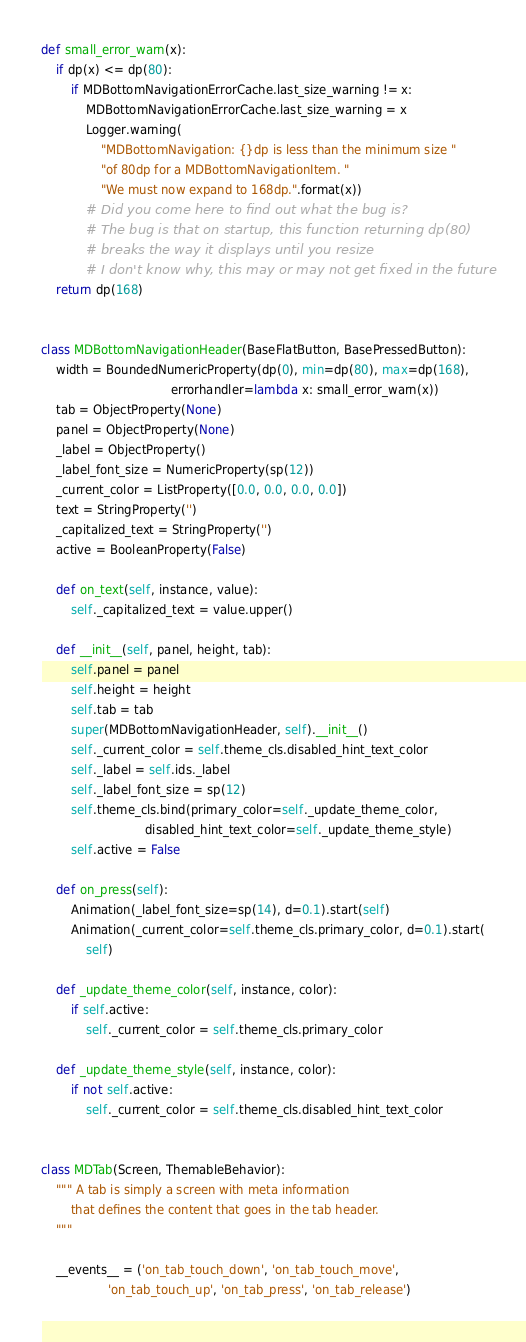<code> <loc_0><loc_0><loc_500><loc_500><_Python_>def small_error_warn(x):
    if dp(x) <= dp(80):
        if MDBottomNavigationErrorCache.last_size_warning != x:
            MDBottomNavigationErrorCache.last_size_warning = x
            Logger.warning(
                "MDBottomNavigation: {}dp is less than the minimum size "
                "of 80dp for a MDBottomNavigationItem. "
                "We must now expand to 168dp.".format(x))
            # Did you come here to find out what the bug is?
            # The bug is that on startup, this function returning dp(80)
            # breaks the way it displays until you resize
            # I don't know why, this may or may not get fixed in the future
    return dp(168)


class MDBottomNavigationHeader(BaseFlatButton, BasePressedButton):
    width = BoundedNumericProperty(dp(0), min=dp(80), max=dp(168),
                                   errorhandler=lambda x: small_error_warn(x))
    tab = ObjectProperty(None)
    panel = ObjectProperty(None)
    _label = ObjectProperty()
    _label_font_size = NumericProperty(sp(12))
    _current_color = ListProperty([0.0, 0.0, 0.0, 0.0])
    text = StringProperty('')
    _capitalized_text = StringProperty('')
    active = BooleanProperty(False)

    def on_text(self, instance, value):
        self._capitalized_text = value.upper()

    def __init__(self, panel, height, tab):
        self.panel = panel
        self.height = height
        self.tab = tab
        super(MDBottomNavigationHeader, self).__init__()
        self._current_color = self.theme_cls.disabled_hint_text_color
        self._label = self.ids._label
        self._label_font_size = sp(12)
        self.theme_cls.bind(primary_color=self._update_theme_color,
                            disabled_hint_text_color=self._update_theme_style)
        self.active = False

    def on_press(self):
        Animation(_label_font_size=sp(14), d=0.1).start(self)
        Animation(_current_color=self.theme_cls.primary_color, d=0.1).start(
            self)

    def _update_theme_color(self, instance, color):
        if self.active:
            self._current_color = self.theme_cls.primary_color

    def _update_theme_style(self, instance, color):
        if not self.active:
            self._current_color = self.theme_cls.disabled_hint_text_color


class MDTab(Screen, ThemableBehavior):
    """ A tab is simply a screen with meta information
        that defines the content that goes in the tab header.
    """

    __events__ = ('on_tab_touch_down', 'on_tab_touch_move',
                  'on_tab_touch_up', 'on_tab_press', 'on_tab_release')
</code> 